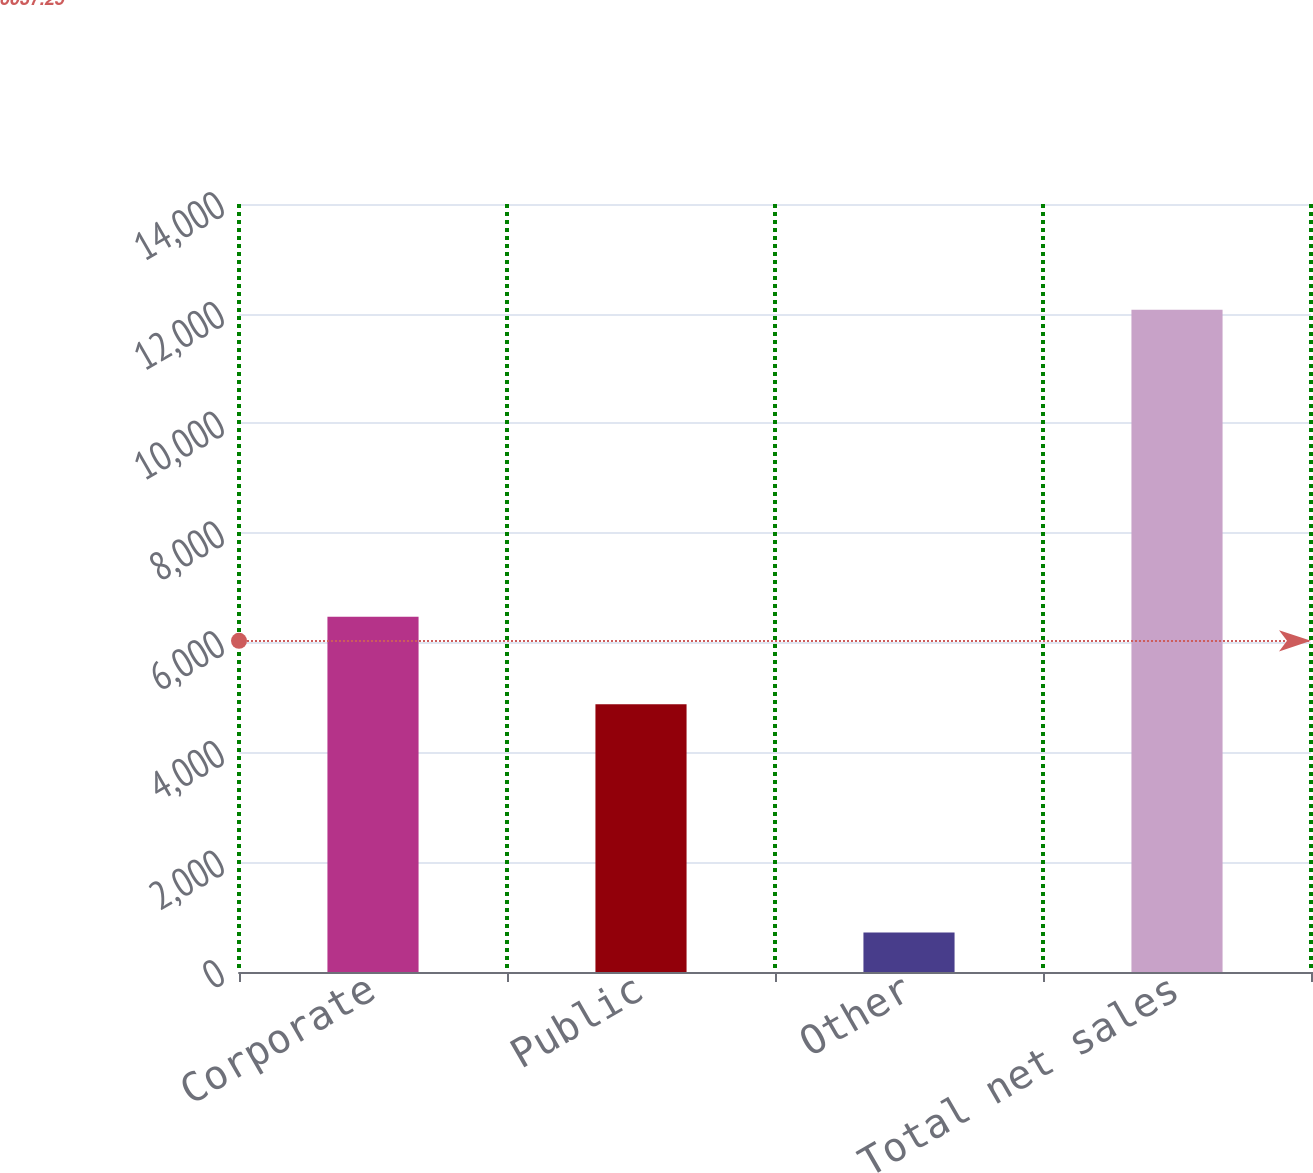<chart> <loc_0><loc_0><loc_500><loc_500><bar_chart><fcel>Corporate<fcel>Public<fcel>Other<fcel>Total net sales<nl><fcel>6475.5<fcel>4879.4<fcel>719.6<fcel>12074.5<nl></chart> 